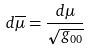<formula> <loc_0><loc_0><loc_500><loc_500>d \overline { \mu } = \frac { d \mu } { \sqrt { g _ { 0 0 } } }</formula> 